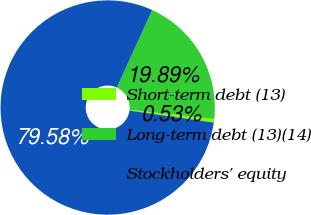Convert chart. <chart><loc_0><loc_0><loc_500><loc_500><pie_chart><fcel>Short-term debt (13)<fcel>Long-term debt (13)(14)<fcel>Stockholders' equity<nl><fcel>0.53%<fcel>19.89%<fcel>79.58%<nl></chart> 